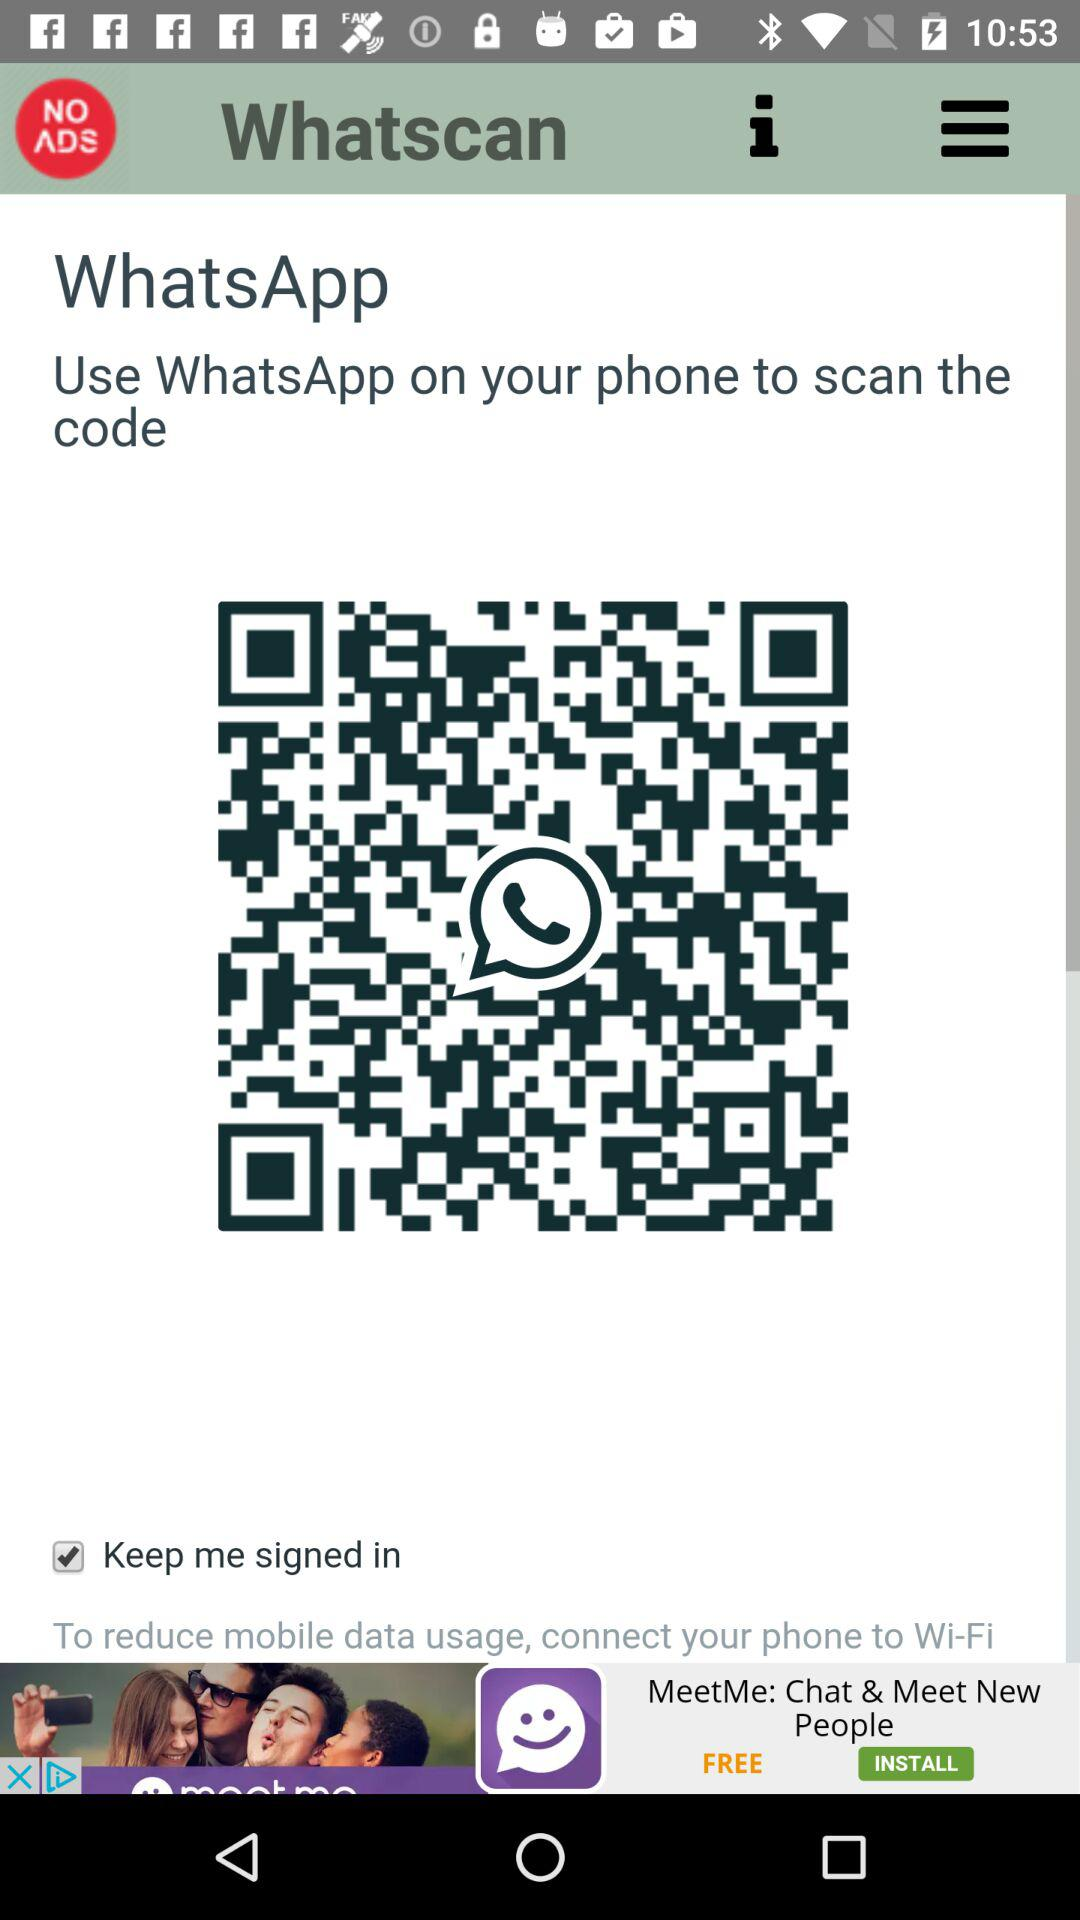What is the application name? The application names are "Whatscan" and "WhatsApp". 